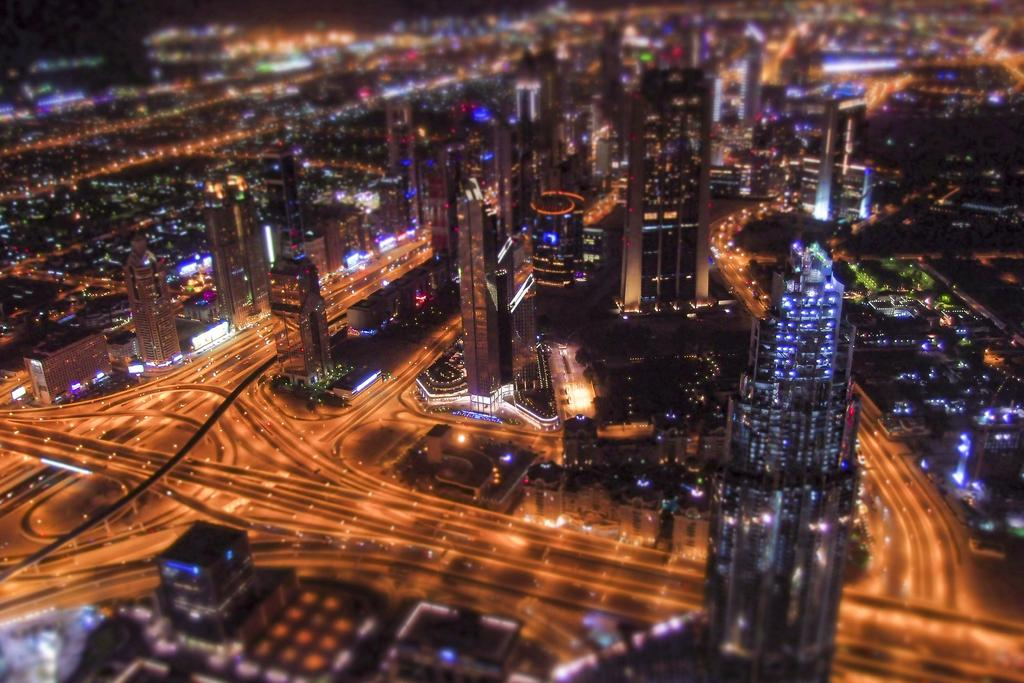What type of structures can be seen in the image? There are buildings in the image. What else is visible in the image besides the buildings? There are roads and lights in the image. Can you describe the background of the image? The background of the image is blurry. What type of creature is sitting on the sofa in the image? There is no sofa or creature present in the image. How many bulbs are visible in the image? There are no bulbs visible in the image. 